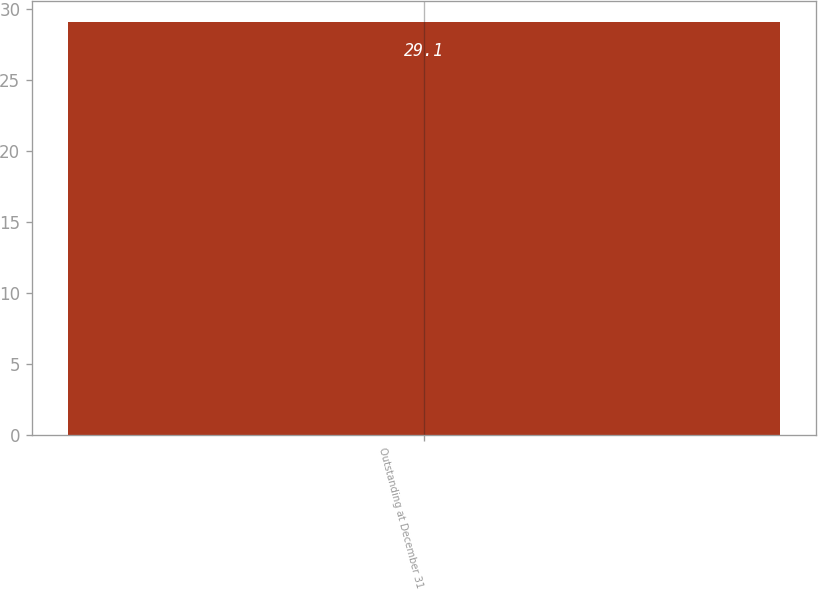Convert chart to OTSL. <chart><loc_0><loc_0><loc_500><loc_500><bar_chart><fcel>Outstanding at December 31<nl><fcel>29.1<nl></chart> 